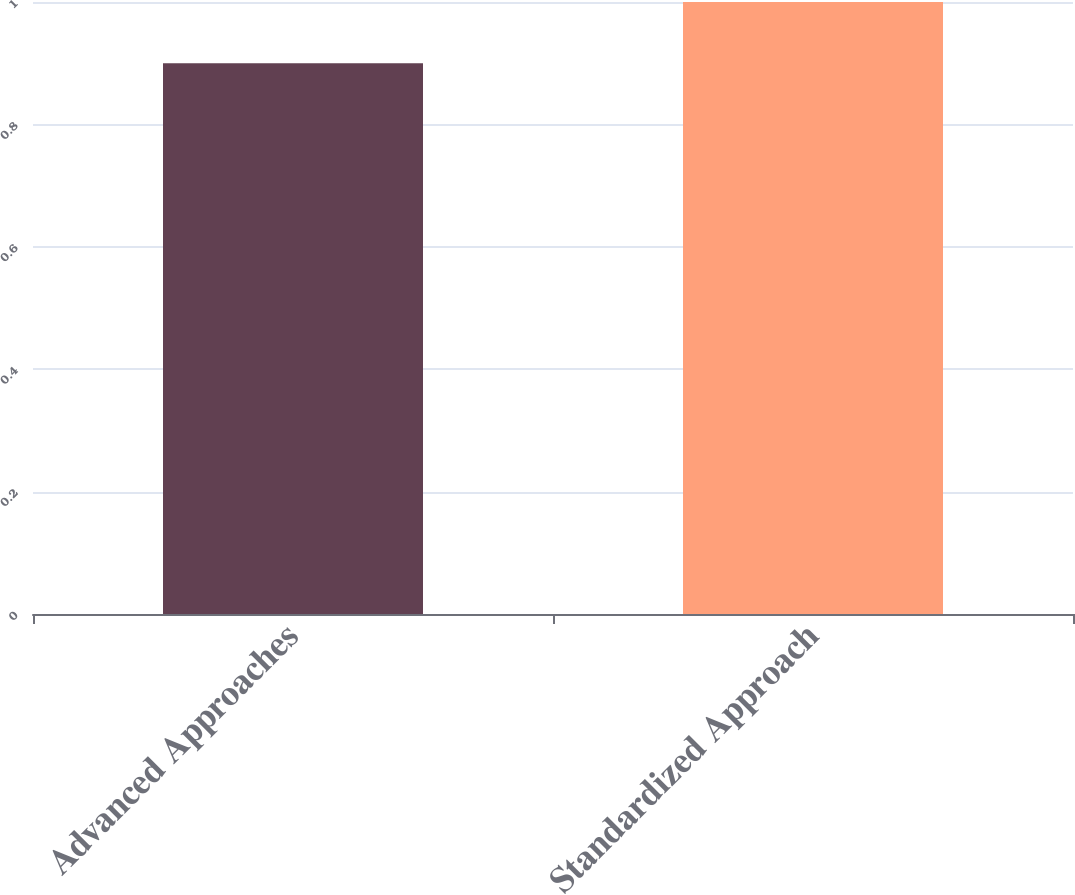Convert chart to OTSL. <chart><loc_0><loc_0><loc_500><loc_500><bar_chart><fcel>Advanced Approaches<fcel>Standardized Approach<nl><fcel>0.9<fcel>1<nl></chart> 